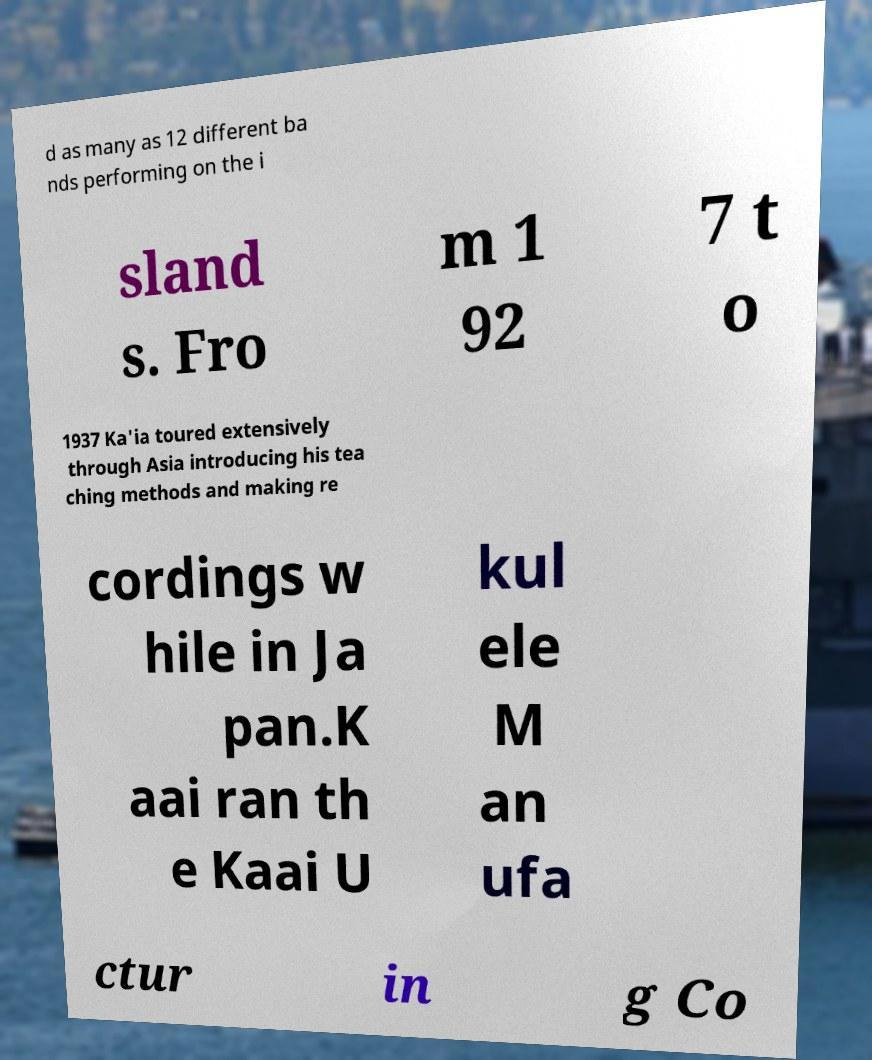For documentation purposes, I need the text within this image transcribed. Could you provide that? d as many as 12 different ba nds performing on the i sland s. Fro m 1 92 7 t o 1937 Ka'ia toured extensively through Asia introducing his tea ching methods and making re cordings w hile in Ja pan.K aai ran th e Kaai U kul ele M an ufa ctur in g Co 